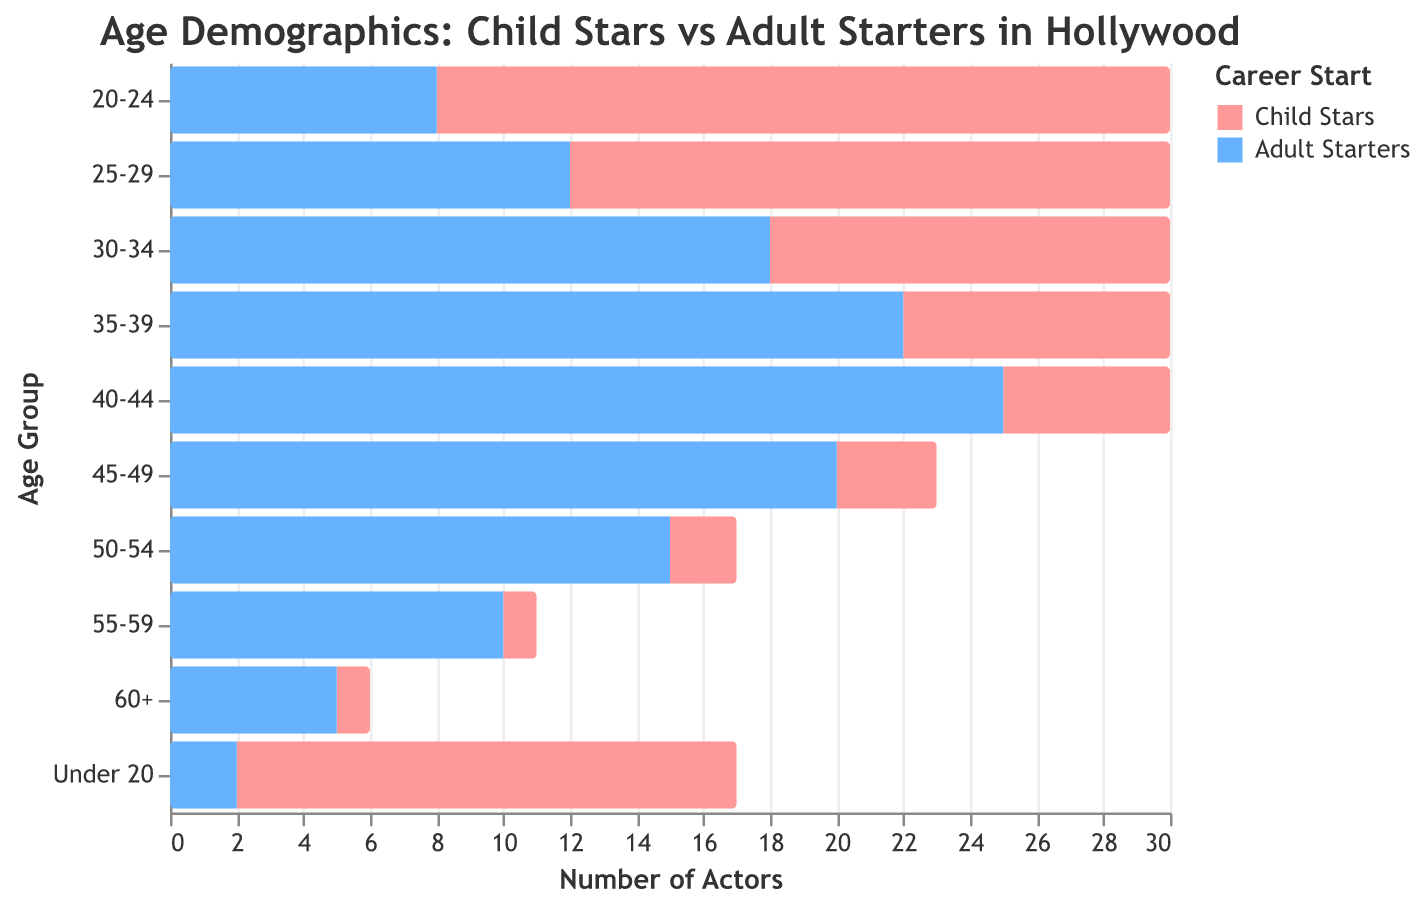What is the title of the figure? Look at the title text at the top of the figure.
Answer: Age Demographics: Child Stars vs Adult Starters in Hollywood Which age group has the highest number of successful actors who started as child stars? Look at the y-axis for the age group and the corresponding bar heights for Child Stars. The tallest bar among Child Stars corresponds to the age group 20-24.
Answer: 20-24 What is the number of successful actors who started their careers as adults in the '40-44' age group? Check the corresponding value on the x-axis for the Adult Starters (blue) bar in the '40-44' age group.
Answer: 25 Which age group has more child stars than adult starters, '25-29' or '30-34'? Compare the values of Child Stars and Adult Starters in both age groups. In '25-29', 18 (Child Stars) is greater than 12 (Adult Starters), while in '30-34', 12 (Child Stars) is less than 18 (Adult Starters).
Answer: 25-29 What is the difference in the number of actors between Child Stars and Adult Starters in the '55-59' age group? Subtract the number of Adult Starters (10) from Child Stars (1) in the '55-59' age group.
Answer: 1 - 10 = -9 How many age groups have fewer than 5 child stars? Count the age groups where the bar height for Child Stars is less than 5. These groups are '45-49', '50-54', '55-59', and '60+'.
Answer: 4 Which category, Child Stars or Adult Starters, has a broader range of representation across age groups? By observing the spread of values for each category, Adult Starters have a wider range covering more significant numbers across more age groups compared to Child Stars.
Answer: Adult Starters In the '35-39' age group, are there more Adult Starters or Child Stars, and by how much? Compare the values in the '35-39' age group: Child Stars (8) and Adult Starters (22). Calculate the difference.
Answer: Adult Starters by 14 What can you infer about the proportion of successful actors who started as adults in their 50s compared to their 20s? Compare the values: '50-54' has 15 Adult Starters, while '20-24' has 8 Adult Starters. The number of Adult Starters is higher in the '50-54' age group.
Answer: More Adult Starters in their 50s Which age group shows the closest number of Child Stars to Adult Starters? Check the age groups for the smallest difference between Child Stars and Adult Starters: In the '60+' age group, there is 1 Child Star and 5 Adult Starters. The difference is small compared to other groups.
Answer: 60+ 